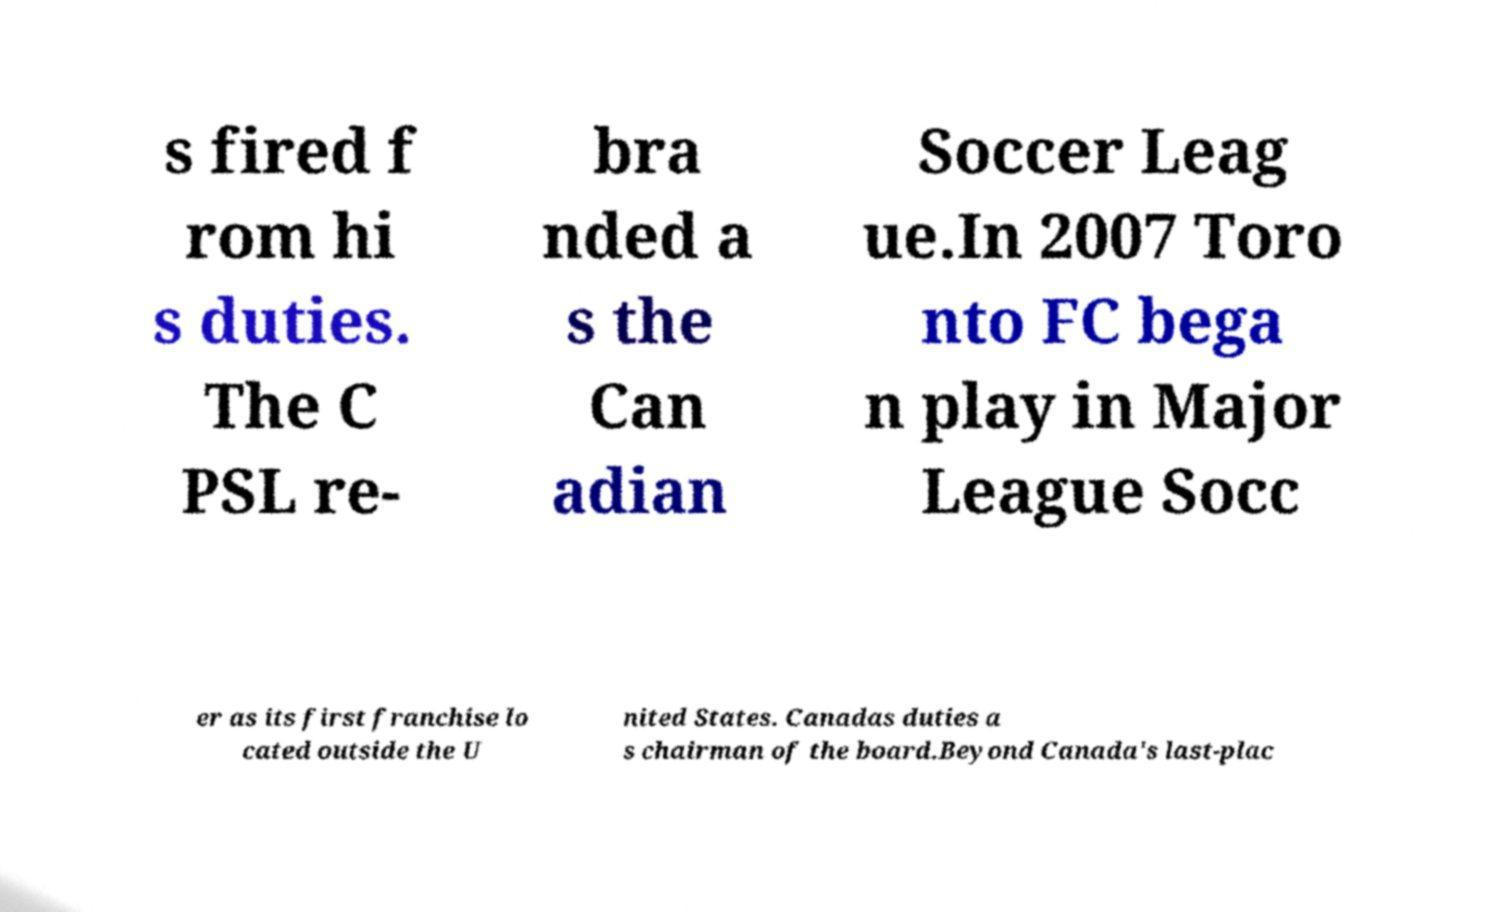Can you accurately transcribe the text from the provided image for me? s fired f rom hi s duties. The C PSL re- bra nded a s the Can adian Soccer Leag ue.In 2007 Toro nto FC bega n play in Major League Socc er as its first franchise lo cated outside the U nited States. Canadas duties a s chairman of the board.Beyond Canada's last-plac 